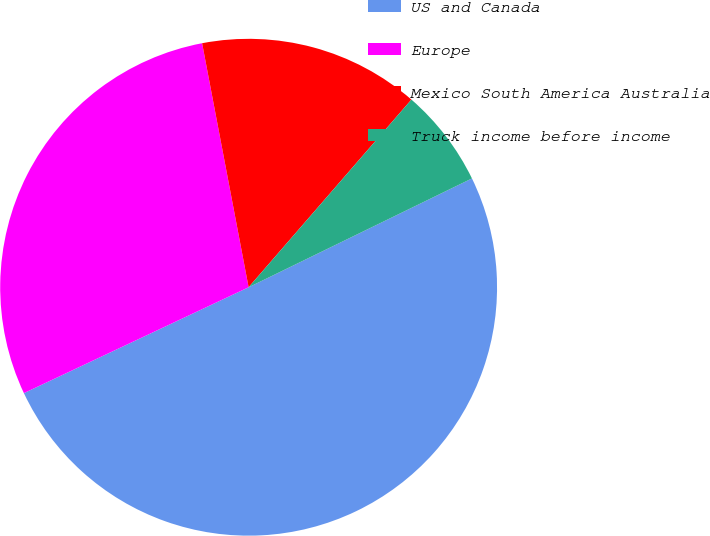Convert chart. <chart><loc_0><loc_0><loc_500><loc_500><pie_chart><fcel>US and Canada<fcel>Europe<fcel>Mexico South America Australia<fcel>Truck income before income<nl><fcel>50.21%<fcel>29.01%<fcel>14.37%<fcel>6.41%<nl></chart> 